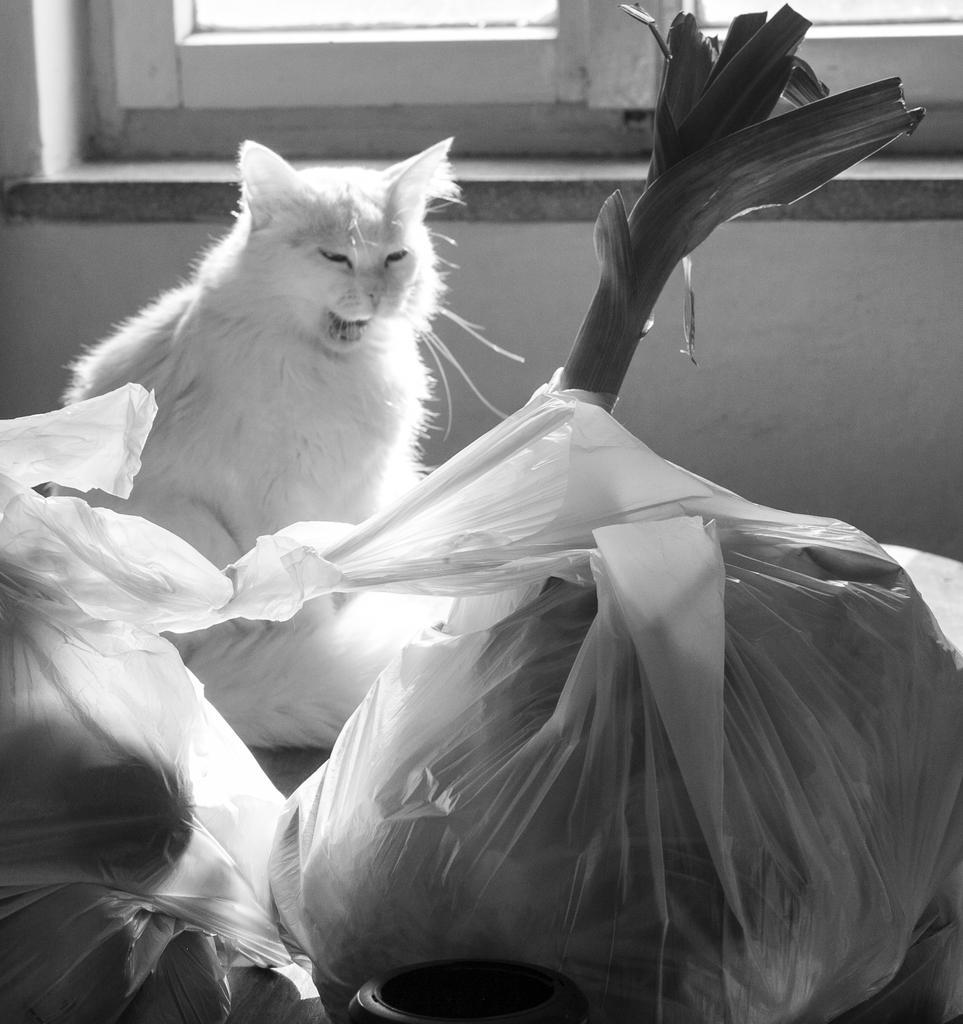Could you give a brief overview of what you see in this image? This is a black and white image where we can see some objects are kept in the cover, we can see a plant, a cat and we can see the windows. 